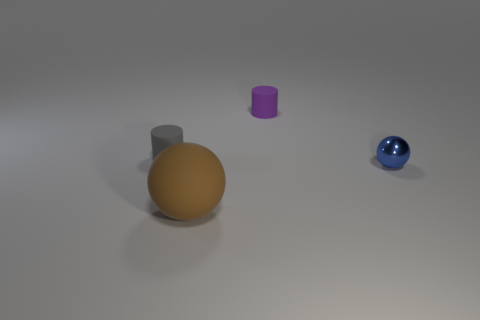What number of tiny objects are yellow cubes or gray matte things?
Your answer should be very brief. 1. Is the number of tiny purple cylinders greater than the number of tiny blue matte blocks?
Your response must be concise. Yes. Is the material of the gray cylinder the same as the large ball?
Make the answer very short. Yes. Are there any other things that are the same material as the blue object?
Your answer should be compact. No. Is the number of metal objects to the right of the big rubber ball greater than the number of green spheres?
Offer a very short reply. Yes. How many big rubber things have the same shape as the small purple rubber thing?
Give a very brief answer. 0. There is a gray thing that is made of the same material as the brown ball; what is its size?
Your answer should be very brief. Small. There is a object that is both to the right of the big brown rubber ball and behind the blue metallic sphere; what is its color?
Offer a terse response. Purple. How many rubber objects have the same size as the blue shiny ball?
Offer a very short reply. 2. There is a thing that is both in front of the tiny gray object and to the left of the small metal sphere; what is its size?
Provide a succinct answer. Large. 